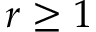<formula> <loc_0><loc_0><loc_500><loc_500>r \geq 1</formula> 